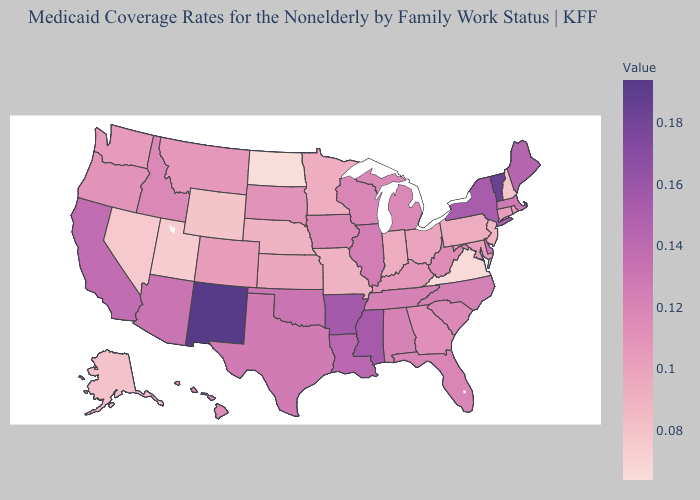Which states have the lowest value in the Northeast?
Short answer required. New Hampshire. Does North Dakota have the lowest value in the MidWest?
Answer briefly. Yes. Does Pennsylvania have a lower value than California?
Be succinct. Yes. Which states have the lowest value in the MidWest?
Concise answer only. North Dakota. Among the states that border South Carolina , does Georgia have the highest value?
Answer briefly. No. Among the states that border Arizona , which have the lowest value?
Write a very short answer. Utah. Does Indiana have the highest value in the MidWest?
Be succinct. No. 